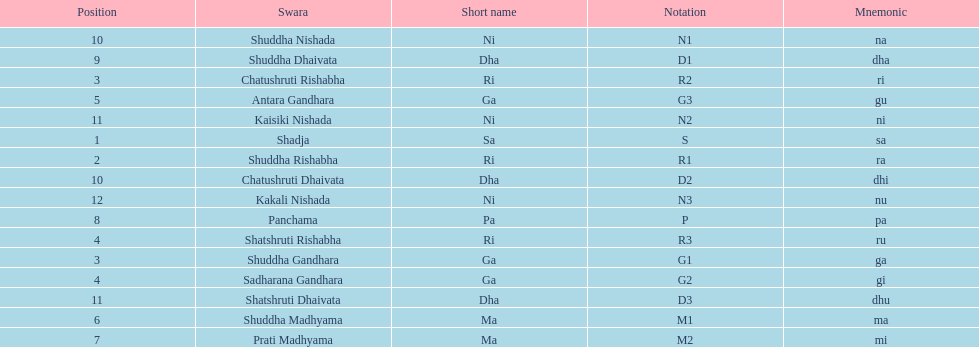Give me the full table as a dictionary. {'header': ['Position', 'Swara', 'Short name', 'Notation', 'Mnemonic'], 'rows': [['10', 'Shuddha Nishada', 'Ni', 'N1', 'na'], ['9', 'Shuddha Dhaivata', 'Dha', 'D1', 'dha'], ['3', 'Chatushruti Rishabha', 'Ri', 'R2', 'ri'], ['5', 'Antara Gandhara', 'Ga', 'G3', 'gu'], ['11', 'Kaisiki Nishada', 'Ni', 'N2', 'ni'], ['1', 'Shadja', 'Sa', 'S', 'sa'], ['2', 'Shuddha Rishabha', 'Ri', 'R1', 'ra'], ['10', 'Chatushruti Dhaivata', 'Dha', 'D2', 'dhi'], ['12', 'Kakali Nishada', 'Ni', 'N3', 'nu'], ['8', 'Panchama', 'Pa', 'P', 'pa'], ['4', 'Shatshruti Rishabha', 'Ri', 'R3', 'ru'], ['3', 'Shuddha Gandhara', 'Ga', 'G1', 'ga'], ['4', 'Sadharana Gandhara', 'Ga', 'G2', 'gi'], ['11', 'Shatshruti Dhaivata', 'Dha', 'D3', 'dhu'], ['6', 'Shuddha Madhyama', 'Ma', 'M1', 'ma'], ['7', 'Prati Madhyama', 'Ma', 'M2', 'mi']]} How many swaras do not have dhaivata in their name? 13. 